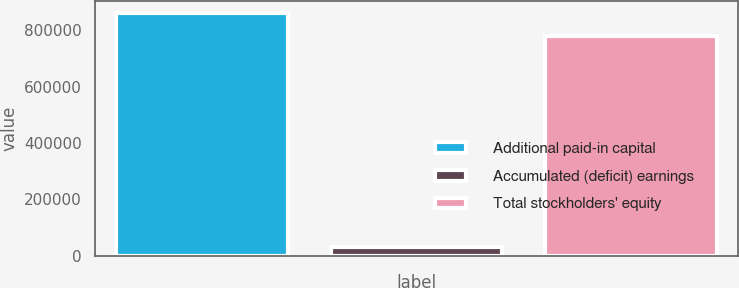Convert chart. <chart><loc_0><loc_0><loc_500><loc_500><bar_chart><fcel>Additional paid-in capital<fcel>Accumulated (deficit) earnings<fcel>Total stockholders' equity<nl><fcel>859922<fcel>29602<fcel>781136<nl></chart> 